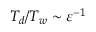<formula> <loc_0><loc_0><loc_500><loc_500>T _ { d } / T _ { w } \sim { \varepsilon } ^ { - 1 }</formula> 